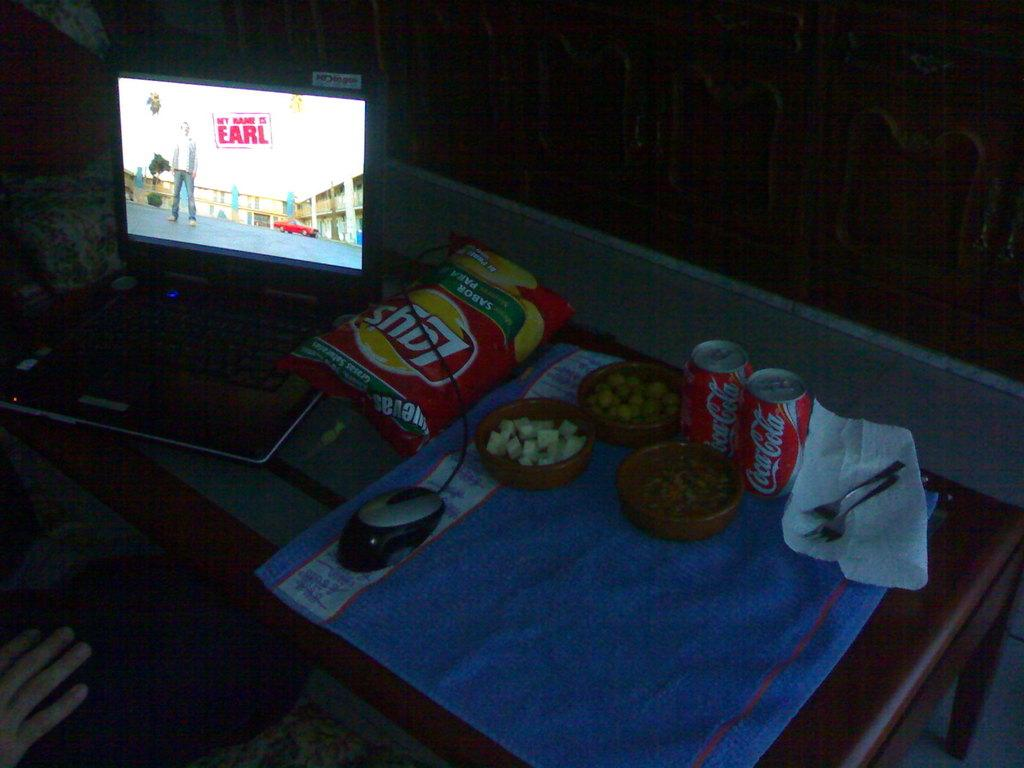<image>
Describe the image concisely. Two cans of Coca-Cola and Lays sit on a table while My Name is Earl is playing. 